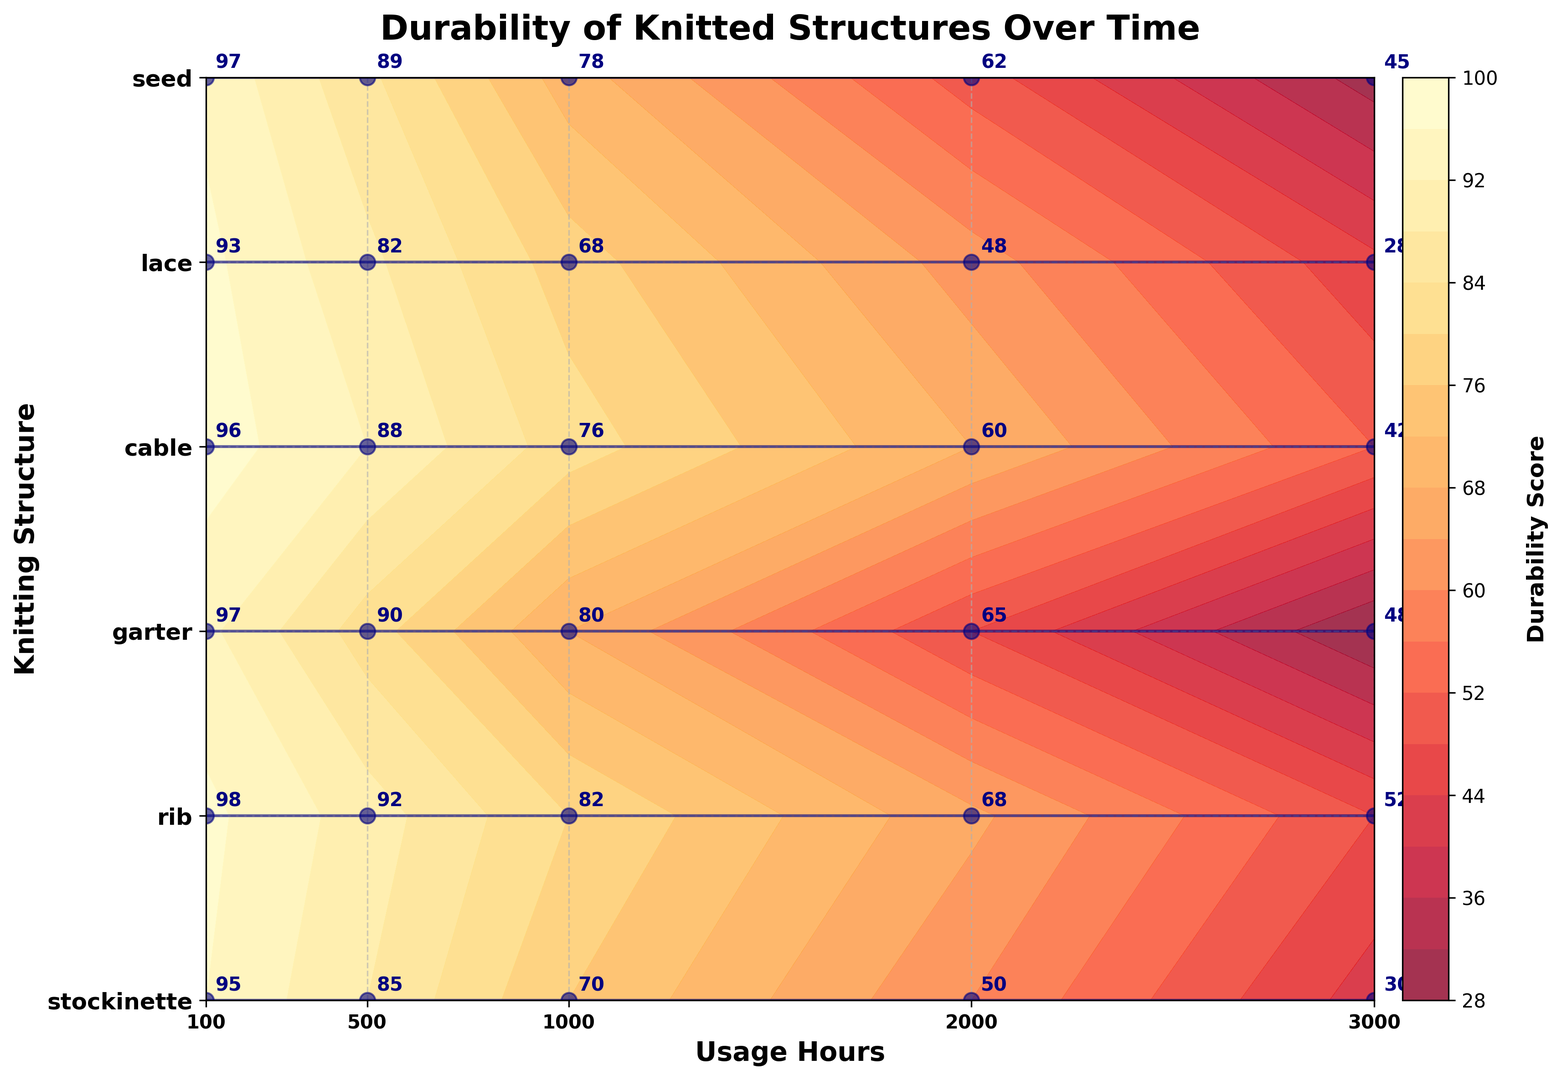what is the durability score of the rib structure after 1000 usage hours? Look at the durability score for the rib structure at 1000 usage hours. This is indicated by the annotation on the plot for the rib structure.
Answer: 82 which structure has the highest durability score at 500 usage hours? Compare the durability scores of all structures at 500 usage hours by looking at the 500-hour vertical line. Identify the structure with the highest score.
Answer: rib What is the average durability score for the cable structure across all usage hours? Add the durability scores of the cable structure at all usage hours (100, 500, 1000, 2000, 3000) and divide by the number of observations (5). Calculation: (96 + 88 + 76 + 60 + 42) / 5 = 72.4
Answer: 72.4 Which structure shows the steepest decline in durability score from 1000 to 3000 usage hours? Calculate the difference in durability scores between 1000 and 3000 usage hours for each structure, and identify the structure with the largest negative change. Differences: stockinette (70-30=40), rib (82-52=30), garter (80-48=32), cable (76-42=34), lace (68-28=40), seed (78-45=33). Therefore, stockinette and lace both have a decline of 40.
Answer: stockinette or lace For which structure does the durability score drop below 50 first as usage hours increase? Identify the usage hour at which each structure's durability score drops below 50 hours and determine which structure reaches this threshold first. lace drops below 50 first at 2000 hours.
Answer: lace What is the overall trend in durability scores for stockinette over increasing usage hours? Check how the durability scores of stockinette change as usage hours progress from 100 to 3000. The trend is a steady decline.
Answer: Steady decline Which structure maintains a durability score above 60 for the longest duration? Find the structure with durability scores above 60 and check until what usage hours they last above 60. Rib and seed maintain above 60 till 2000 hours.
Answer: rib or seed How does the durability score of garter at 2000 usage hours compare with the durability score of lace at the same usage hours? Look at the durability scores of garter and lace at 2000 usage hours and compare them. Garter is 65, lace is 48.
Answer: Garter is higher What's the difference in durability scores between cable and seed structures at 3000 usage hours? Subtract the durability score of the cable structure from the seed structure at 3000 usage hours. Calculation: 45 - 42 = 3.
Answer: 3 What is the visual appearance of the contour for the rib structure compared to the lace structure? Describe the density and color of the contours around the rib and lace structures to detail their visual differences. Rib has a denser and darker contour compared to lace, indicating higher durability scores.
Answer: Rib is denser and darker 